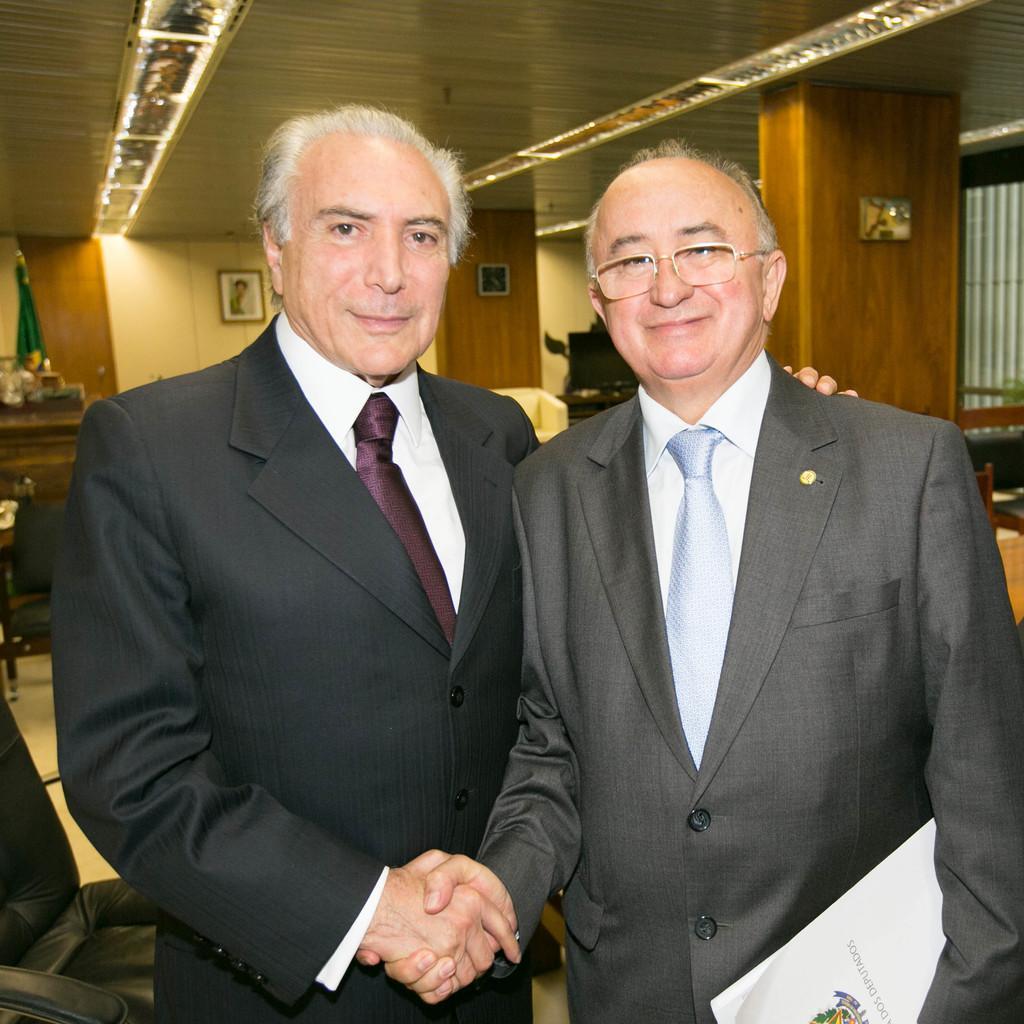How would you summarize this image in a sentence or two? In this picture we can see two persons,one person is wearing spectacles and in the background we can see a wall. 